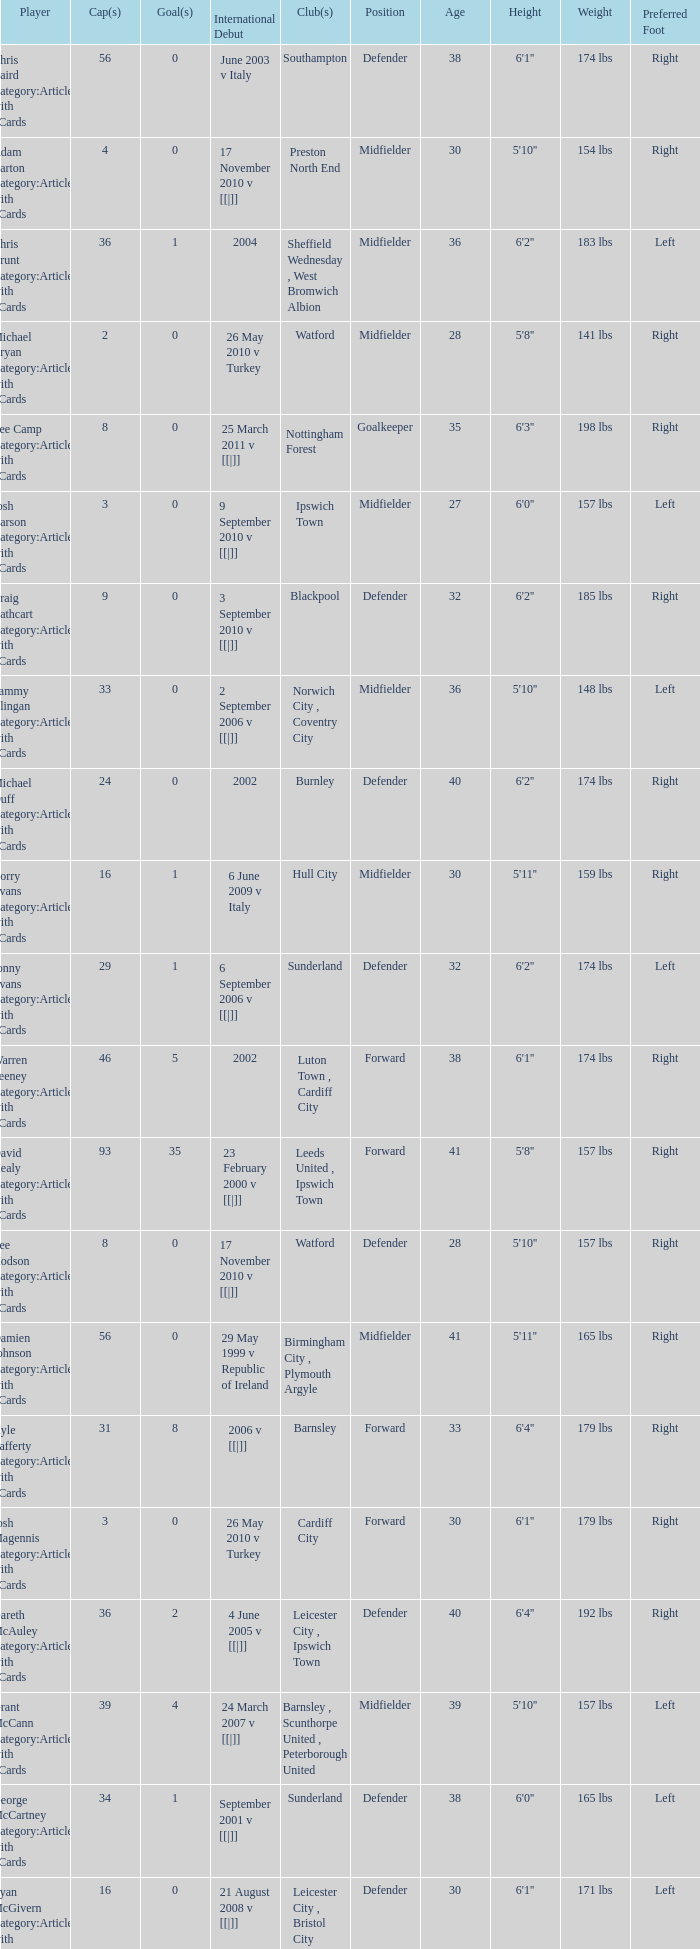How many players had 8 goals? 1.0. 